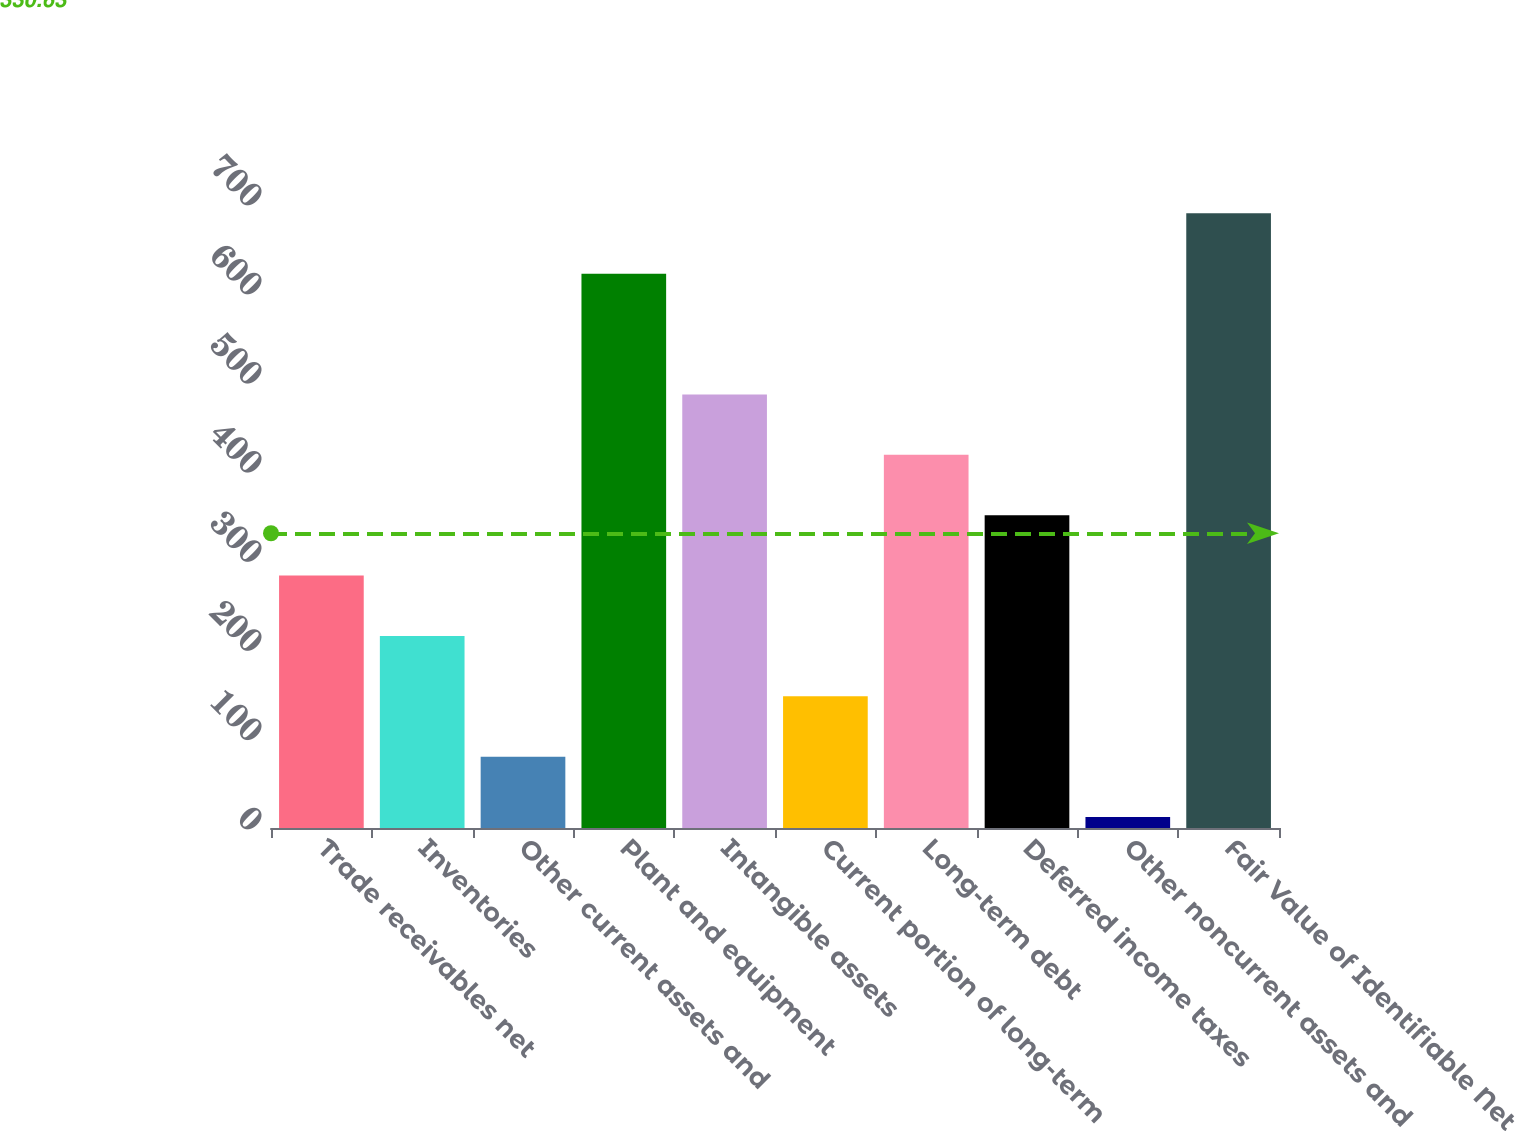Convert chart. <chart><loc_0><loc_0><loc_500><loc_500><bar_chart><fcel>Trade receivables net<fcel>Inventories<fcel>Other current assets and<fcel>Plant and equipment<fcel>Intangible assets<fcel>Current portion of long-term<fcel>Long-term debt<fcel>Deferred income taxes<fcel>Other noncurrent assets and<fcel>Fair Value of Identifiable Net<nl><fcel>283.22<fcel>215.49<fcel>80.03<fcel>621.87<fcel>486.41<fcel>147.76<fcel>418.68<fcel>350.95<fcel>12.3<fcel>689.6<nl></chart> 